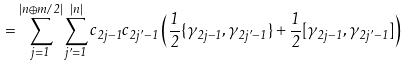Convert formula to latex. <formula><loc_0><loc_0><loc_500><loc_500>= \sum _ { j = 1 } ^ { | n \oplus m / 2 | } \sum _ { j ^ { \prime } = 1 } ^ { | n | } c _ { 2 j - 1 } c _ { 2 j ^ { \prime } - 1 } \left ( \frac { 1 } { 2 } \{ \gamma _ { 2 j - 1 } , \gamma _ { 2 j ^ { \prime } - 1 } \} + \frac { 1 } { 2 } [ \gamma _ { 2 j - 1 } , \gamma _ { 2 j ^ { \prime } - 1 } ] \right )</formula> 